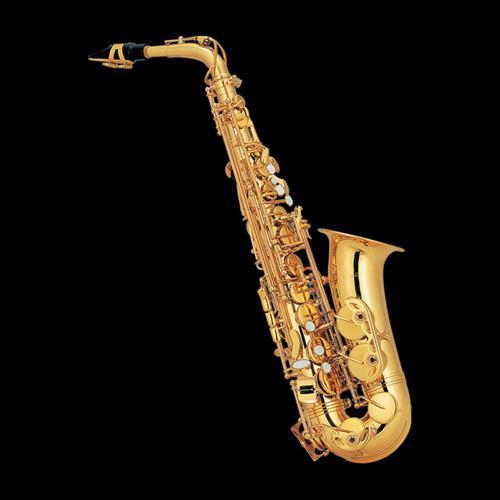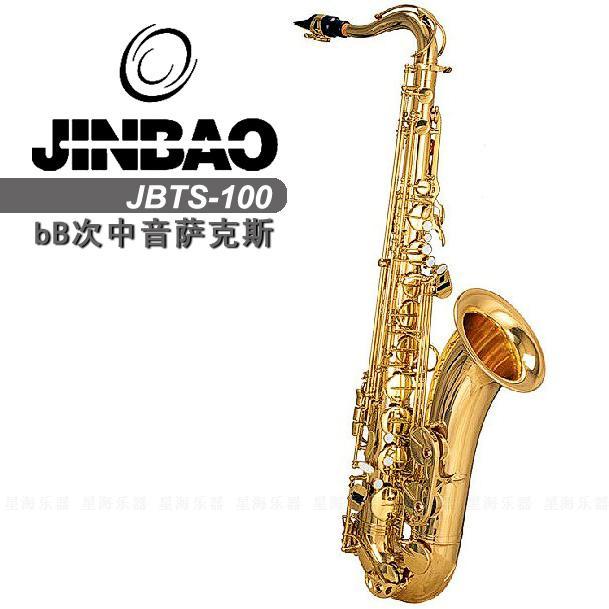The first image is the image on the left, the second image is the image on the right. Evaluate the accuracy of this statement regarding the images: "Each image contains one saxophone displayed with its bell facing rightward and its mouthpiece pointing leftward, and each saxophone has a curved bell end.". Is it true? Answer yes or no. Yes. The first image is the image on the left, the second image is the image on the right. Analyze the images presented: Is the assertion "There are exactly two saxophones with their mouthpiece pointing to the left." valid? Answer yes or no. Yes. 